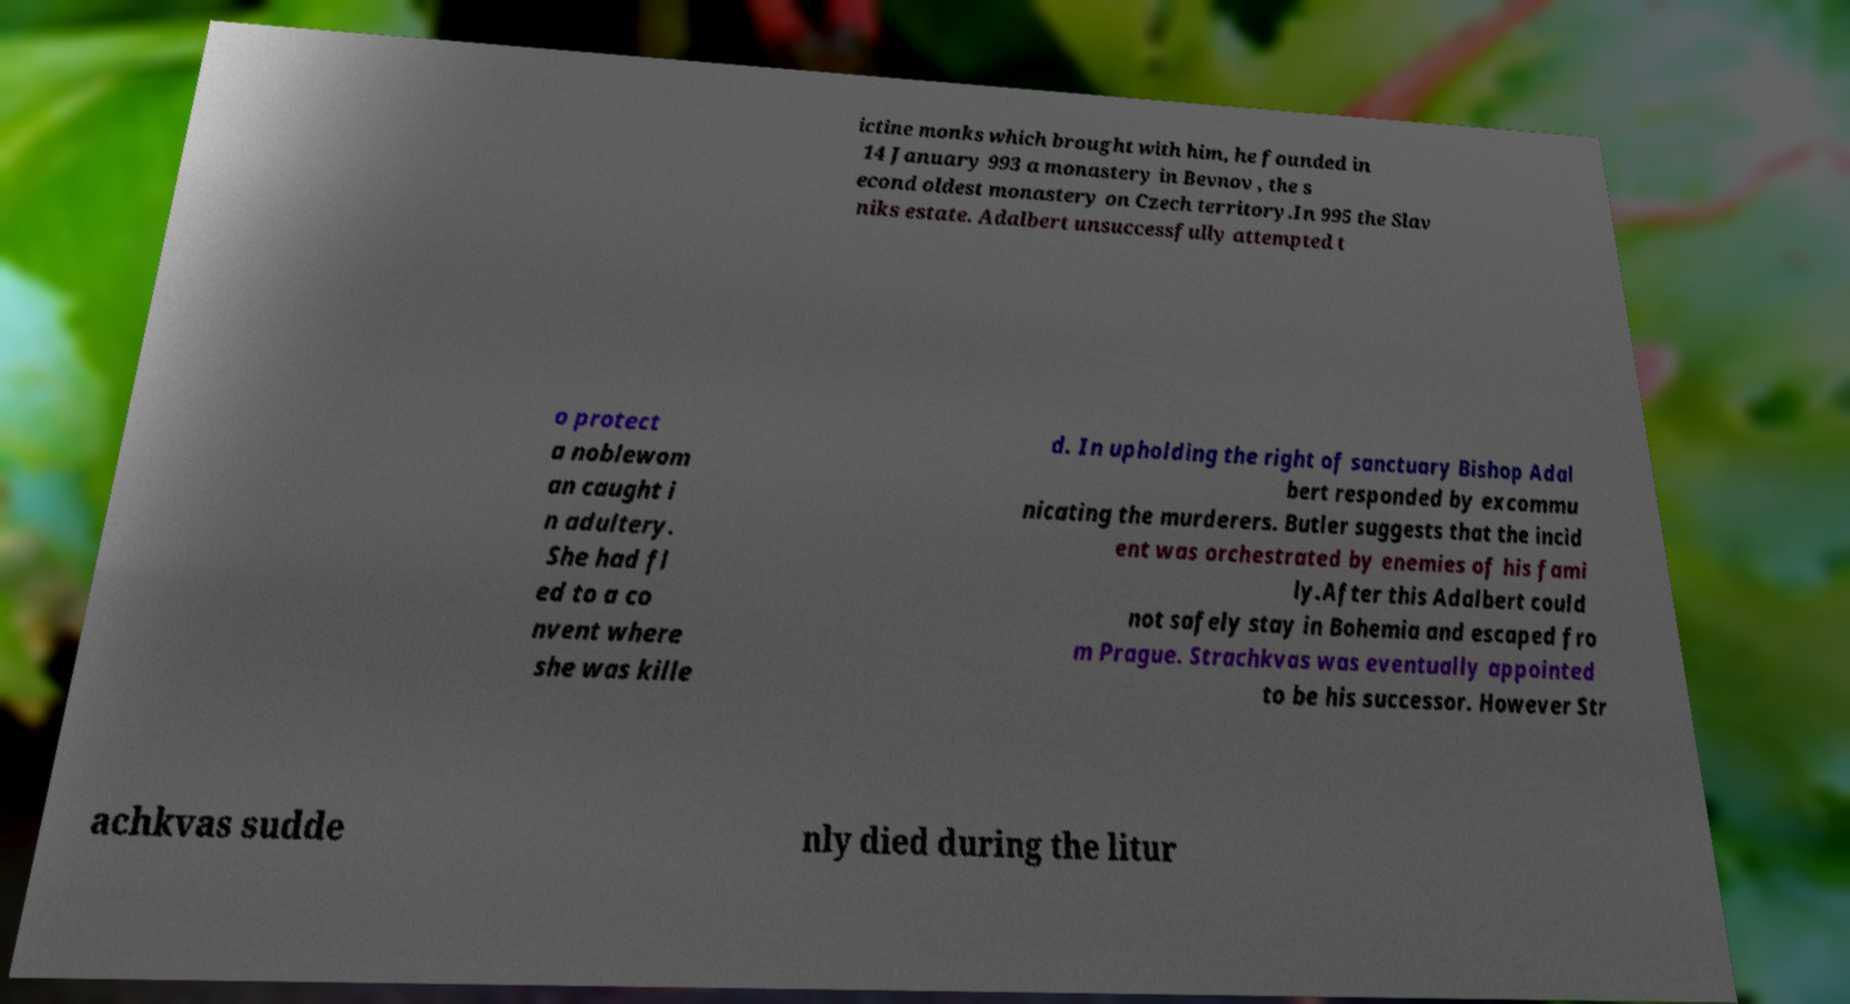Can you accurately transcribe the text from the provided image for me? ictine monks which brought with him, he founded in 14 January 993 a monastery in Bevnov , the s econd oldest monastery on Czech territory.In 995 the Slav niks estate. Adalbert unsuccessfully attempted t o protect a noblewom an caught i n adultery. She had fl ed to a co nvent where she was kille d. In upholding the right of sanctuary Bishop Adal bert responded by excommu nicating the murderers. Butler suggests that the incid ent was orchestrated by enemies of his fami ly.After this Adalbert could not safely stay in Bohemia and escaped fro m Prague. Strachkvas was eventually appointed to be his successor. However Str achkvas sudde nly died during the litur 